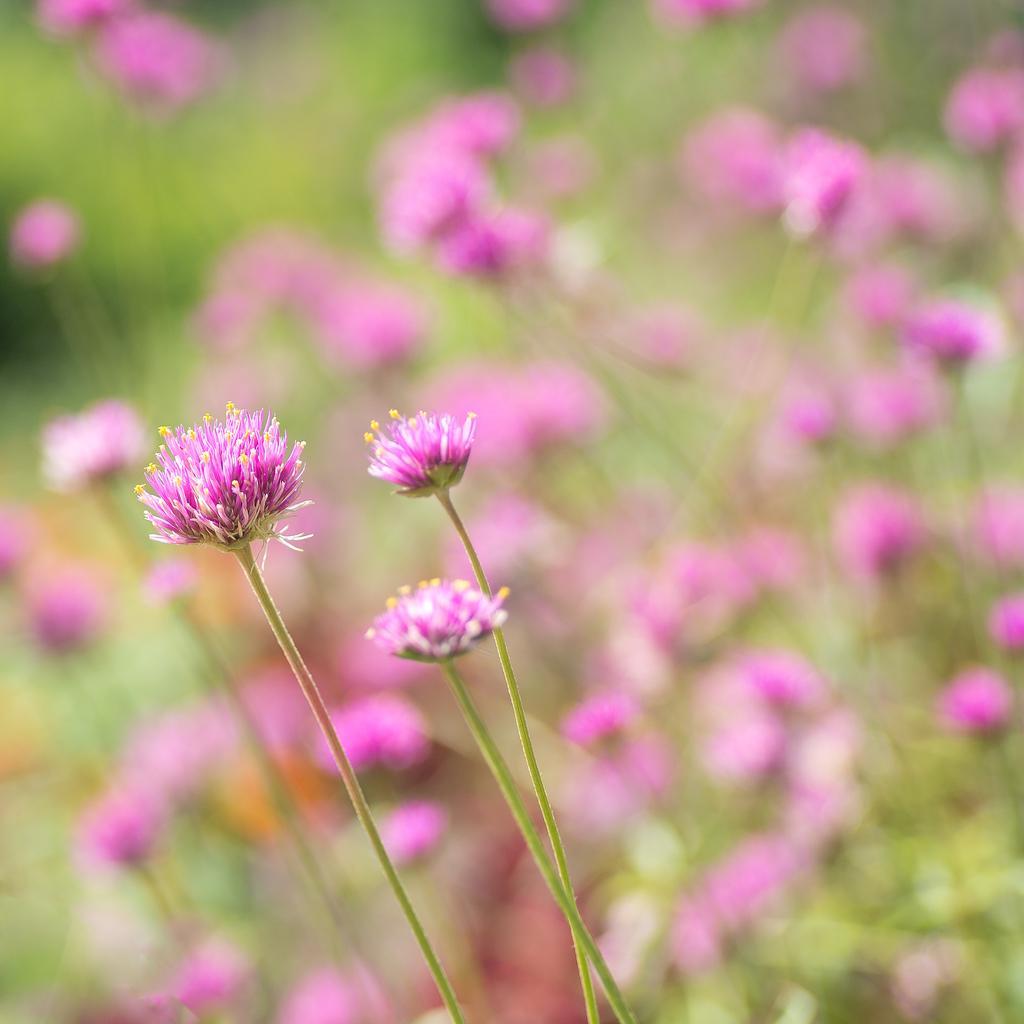Can you describe this image briefly? In the image we can see flowers, pink in color. This is a stem of the flower and the background is blurred. 